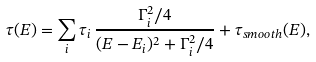Convert formula to latex. <formula><loc_0><loc_0><loc_500><loc_500>\tau ( E ) = \sum _ { i } \tau _ { i } \, \frac { \Gamma _ { i } ^ { 2 } / 4 } { ( E - E _ { i } ) ^ { 2 } + \Gamma _ { i } ^ { 2 } / 4 } + \tau _ { s m o o t h } ( E ) ,</formula> 